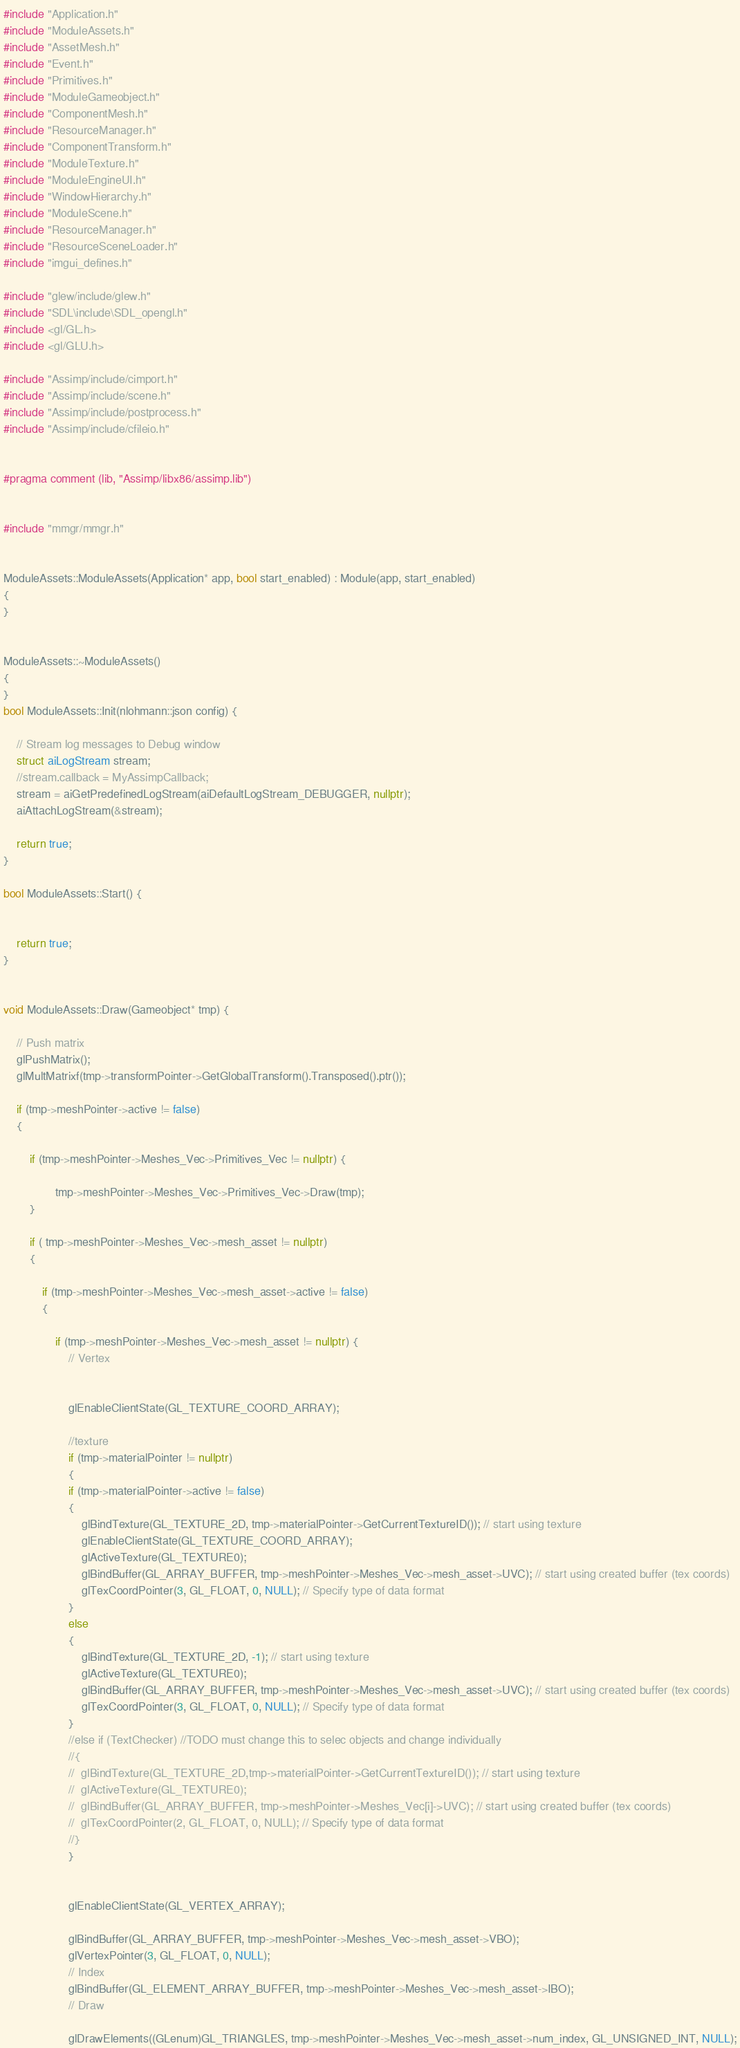Convert code to text. <code><loc_0><loc_0><loc_500><loc_500><_C++_>
#include "Application.h"
#include "ModuleAssets.h"
#include "AssetMesh.h"
#include "Event.h"
#include "Primitives.h"
#include "ModuleGameobject.h"
#include "ComponentMesh.h"
#include "ResourceManager.h"
#include "ComponentTransform.h"
#include "ModuleTexture.h"
#include "ModuleEngineUI.h"
#include "WindowHierarchy.h"
#include "ModuleScene.h"
#include "ResourceManager.h"
#include "ResourceSceneLoader.h"
#include "imgui_defines.h"

#include "glew/include/glew.h"
#include "SDL\include\SDL_opengl.h"
#include <gl/GL.h>
#include <gl/GLU.h>

#include "Assimp/include/cimport.h"
#include "Assimp/include/scene.h"
#include "Assimp/include/postprocess.h"
#include "Assimp/include/cfileio.h"


#pragma comment (lib, "Assimp/libx86/assimp.lib")


#include "mmgr/mmgr.h"


ModuleAssets::ModuleAssets(Application* app, bool start_enabled) : Module(app, start_enabled)
{
}


ModuleAssets::~ModuleAssets()
{
}
bool ModuleAssets::Init(nlohmann::json config) {

	// Stream log messages to Debug window
	struct aiLogStream stream;
	//stream.callback = MyAssimpCallback;
	stream = aiGetPredefinedLogStream(aiDefaultLogStream_DEBUGGER, nullptr);
	aiAttachLogStream(&stream);

	return true;
}

bool ModuleAssets::Start() {


	return true;
}


void ModuleAssets::Draw(Gameobject* tmp) {

	// Push matrix
	glPushMatrix();
	glMultMatrixf(tmp->transformPointer->GetGlobalTransform().Transposed().ptr());

	if (tmp->meshPointer->active != false)
	{

		if (tmp->meshPointer->Meshes_Vec->Primitives_Vec != nullptr) {

				tmp->meshPointer->Meshes_Vec->Primitives_Vec->Draw(tmp);
		}

		if ( tmp->meshPointer->Meshes_Vec->mesh_asset != nullptr)
		{

			if (tmp->meshPointer->Meshes_Vec->mesh_asset->active != false)
			{

				if (tmp->meshPointer->Meshes_Vec->mesh_asset != nullptr) {
					// Vertex


					glEnableClientState(GL_TEXTURE_COORD_ARRAY);

					//texture
					if (tmp->materialPointer != nullptr)
					{
					if (tmp->materialPointer->active != false)
					{
						glBindTexture(GL_TEXTURE_2D, tmp->materialPointer->GetCurrentTextureID()); // start using texture
						glEnableClientState(GL_TEXTURE_COORD_ARRAY);
						glActiveTexture(GL_TEXTURE0);
						glBindBuffer(GL_ARRAY_BUFFER, tmp->meshPointer->Meshes_Vec->mesh_asset->UVC); // start using created buffer (tex coords)
						glTexCoordPointer(3, GL_FLOAT, 0, NULL); // Specify type of data format
					}
					else
					{
						glBindTexture(GL_TEXTURE_2D, -1); // start using texture
						glActiveTexture(GL_TEXTURE0);
						glBindBuffer(GL_ARRAY_BUFFER, tmp->meshPointer->Meshes_Vec->mesh_asset->UVC); // start using created buffer (tex coords)
						glTexCoordPointer(3, GL_FLOAT, 0, NULL); // Specify type of data format
					}
					//else if (TextChecker) //TODO must change this to selec objects and change individually
					//{
					//	glBindTexture(GL_TEXTURE_2D,tmp->materialPointer->GetCurrentTextureID()); // start using texture
					//	glActiveTexture(GL_TEXTURE0);
					//	glBindBuffer(GL_ARRAY_BUFFER, tmp->meshPointer->Meshes_Vec[i]->UVC); // start using created buffer (tex coords)
					//	glTexCoordPointer(2, GL_FLOAT, 0, NULL); // Specify type of data format
					//}
					}


					glEnableClientState(GL_VERTEX_ARRAY);

					glBindBuffer(GL_ARRAY_BUFFER, tmp->meshPointer->Meshes_Vec->mesh_asset->VBO);
					glVertexPointer(3, GL_FLOAT, 0, NULL);
					// Index
					glBindBuffer(GL_ELEMENT_ARRAY_BUFFER, tmp->meshPointer->Meshes_Vec->mesh_asset->IBO);
					// Draw

					glDrawElements((GLenum)GL_TRIANGLES, tmp->meshPointer->Meshes_Vec->mesh_asset->num_index, GL_UNSIGNED_INT, NULL);


</code> 